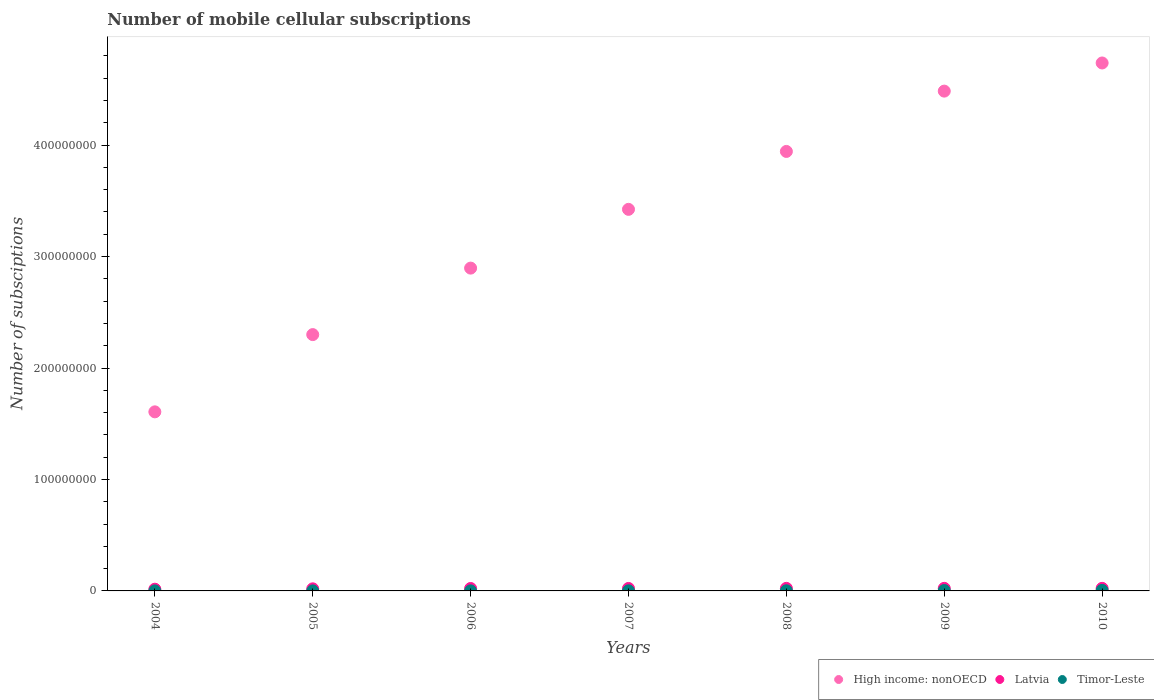What is the number of mobile cellular subscriptions in Latvia in 2010?
Provide a succinct answer. 2.31e+06. Across all years, what is the maximum number of mobile cellular subscriptions in Timor-Leste?
Keep it short and to the point. 4.73e+05. Across all years, what is the minimum number of mobile cellular subscriptions in Timor-Leste?
Your response must be concise. 2.57e+04. In which year was the number of mobile cellular subscriptions in High income: nonOECD maximum?
Offer a terse response. 2010. What is the total number of mobile cellular subscriptions in Latvia in the graph?
Your response must be concise. 1.47e+07. What is the difference between the number of mobile cellular subscriptions in Latvia in 2008 and that in 2009?
Your answer should be very brief. -4990. What is the difference between the number of mobile cellular subscriptions in Timor-Leste in 2006 and the number of mobile cellular subscriptions in Latvia in 2007?
Your response must be concise. -2.17e+06. What is the average number of mobile cellular subscriptions in High income: nonOECD per year?
Make the answer very short. 3.34e+08. In the year 2010, what is the difference between the number of mobile cellular subscriptions in Latvia and number of mobile cellular subscriptions in Timor-Leste?
Your response must be concise. 1.83e+06. What is the ratio of the number of mobile cellular subscriptions in High income: nonOECD in 2005 to that in 2010?
Give a very brief answer. 0.49. Is the number of mobile cellular subscriptions in High income: nonOECD in 2008 less than that in 2010?
Make the answer very short. Yes. What is the difference between the highest and the second highest number of mobile cellular subscriptions in High income: nonOECD?
Your answer should be very brief. 2.53e+07. What is the difference between the highest and the lowest number of mobile cellular subscriptions in Latvia?
Provide a short and direct response. 7.69e+05. Is it the case that in every year, the sum of the number of mobile cellular subscriptions in Latvia and number of mobile cellular subscriptions in Timor-Leste  is greater than the number of mobile cellular subscriptions in High income: nonOECD?
Your answer should be very brief. No. How many years are there in the graph?
Provide a succinct answer. 7. What is the difference between two consecutive major ticks on the Y-axis?
Provide a succinct answer. 1.00e+08. Are the values on the major ticks of Y-axis written in scientific E-notation?
Keep it short and to the point. No. How many legend labels are there?
Give a very brief answer. 3. What is the title of the graph?
Provide a short and direct response. Number of mobile cellular subscriptions. What is the label or title of the X-axis?
Your answer should be compact. Years. What is the label or title of the Y-axis?
Give a very brief answer. Number of subsciptions. What is the Number of subsciptions in High income: nonOECD in 2004?
Offer a very short reply. 1.61e+08. What is the Number of subsciptions of Latvia in 2004?
Give a very brief answer. 1.54e+06. What is the Number of subsciptions of Timor-Leste in 2004?
Your answer should be very brief. 2.57e+04. What is the Number of subsciptions in High income: nonOECD in 2005?
Your response must be concise. 2.30e+08. What is the Number of subsciptions in Latvia in 2005?
Your response must be concise. 1.87e+06. What is the Number of subsciptions in Timor-Leste in 2005?
Your answer should be compact. 3.31e+04. What is the Number of subsciptions in High income: nonOECD in 2006?
Provide a short and direct response. 2.90e+08. What is the Number of subsciptions of Latvia in 2006?
Your answer should be very brief. 2.18e+06. What is the Number of subsciptions of Timor-Leste in 2006?
Keep it short and to the point. 4.91e+04. What is the Number of subsciptions in High income: nonOECD in 2007?
Your answer should be compact. 3.42e+08. What is the Number of subsciptions of Latvia in 2007?
Make the answer very short. 2.22e+06. What is the Number of subsciptions of Timor-Leste in 2007?
Give a very brief answer. 7.82e+04. What is the Number of subsciptions of High income: nonOECD in 2008?
Give a very brief answer. 3.94e+08. What is the Number of subsciptions of Latvia in 2008?
Keep it short and to the point. 2.30e+06. What is the Number of subsciptions in Timor-Leste in 2008?
Provide a succinct answer. 1.25e+05. What is the Number of subsciptions in High income: nonOECD in 2009?
Ensure brevity in your answer.  4.48e+08. What is the Number of subsciptions in Latvia in 2009?
Provide a short and direct response. 2.30e+06. What is the Number of subsciptions of Timor-Leste in 2009?
Your response must be concise. 3.51e+05. What is the Number of subsciptions in High income: nonOECD in 2010?
Your response must be concise. 4.74e+08. What is the Number of subsciptions in Latvia in 2010?
Keep it short and to the point. 2.31e+06. What is the Number of subsciptions of Timor-Leste in 2010?
Your response must be concise. 4.73e+05. Across all years, what is the maximum Number of subsciptions in High income: nonOECD?
Provide a succinct answer. 4.74e+08. Across all years, what is the maximum Number of subsciptions of Latvia?
Offer a terse response. 2.31e+06. Across all years, what is the maximum Number of subsciptions in Timor-Leste?
Make the answer very short. 4.73e+05. Across all years, what is the minimum Number of subsciptions of High income: nonOECD?
Ensure brevity in your answer.  1.61e+08. Across all years, what is the minimum Number of subsciptions in Latvia?
Your response must be concise. 1.54e+06. Across all years, what is the minimum Number of subsciptions of Timor-Leste?
Your answer should be compact. 2.57e+04. What is the total Number of subsciptions of High income: nonOECD in the graph?
Your answer should be compact. 2.34e+09. What is the total Number of subsciptions in Latvia in the graph?
Your response must be concise. 1.47e+07. What is the total Number of subsciptions of Timor-Leste in the graph?
Your answer should be very brief. 1.14e+06. What is the difference between the Number of subsciptions in High income: nonOECD in 2004 and that in 2005?
Provide a short and direct response. -6.93e+07. What is the difference between the Number of subsciptions of Latvia in 2004 and that in 2005?
Your response must be concise. -3.35e+05. What is the difference between the Number of subsciptions in Timor-Leste in 2004 and that in 2005?
Give a very brief answer. -7350. What is the difference between the Number of subsciptions of High income: nonOECD in 2004 and that in 2006?
Your answer should be very brief. -1.29e+08. What is the difference between the Number of subsciptions of Latvia in 2004 and that in 2006?
Offer a terse response. -6.47e+05. What is the difference between the Number of subsciptions in Timor-Leste in 2004 and that in 2006?
Provide a short and direct response. -2.34e+04. What is the difference between the Number of subsciptions in High income: nonOECD in 2004 and that in 2007?
Your response must be concise. -1.82e+08. What is the difference between the Number of subsciptions in Latvia in 2004 and that in 2007?
Offer a terse response. -6.80e+05. What is the difference between the Number of subsciptions of Timor-Leste in 2004 and that in 2007?
Offer a very short reply. -5.25e+04. What is the difference between the Number of subsciptions of High income: nonOECD in 2004 and that in 2008?
Ensure brevity in your answer.  -2.34e+08. What is the difference between the Number of subsciptions in Latvia in 2004 and that in 2008?
Offer a terse response. -7.62e+05. What is the difference between the Number of subsciptions in Timor-Leste in 2004 and that in 2008?
Provide a succinct answer. -9.93e+04. What is the difference between the Number of subsciptions in High income: nonOECD in 2004 and that in 2009?
Offer a terse response. -2.88e+08. What is the difference between the Number of subsciptions in Latvia in 2004 and that in 2009?
Provide a short and direct response. -7.67e+05. What is the difference between the Number of subsciptions of Timor-Leste in 2004 and that in 2009?
Give a very brief answer. -3.25e+05. What is the difference between the Number of subsciptions of High income: nonOECD in 2004 and that in 2010?
Provide a succinct answer. -3.13e+08. What is the difference between the Number of subsciptions of Latvia in 2004 and that in 2010?
Your response must be concise. -7.69e+05. What is the difference between the Number of subsciptions of Timor-Leste in 2004 and that in 2010?
Your response must be concise. -4.47e+05. What is the difference between the Number of subsciptions in High income: nonOECD in 2005 and that in 2006?
Provide a succinct answer. -5.97e+07. What is the difference between the Number of subsciptions of Latvia in 2005 and that in 2006?
Provide a short and direct response. -3.12e+05. What is the difference between the Number of subsciptions in Timor-Leste in 2005 and that in 2006?
Give a very brief answer. -1.60e+04. What is the difference between the Number of subsciptions in High income: nonOECD in 2005 and that in 2007?
Provide a short and direct response. -1.12e+08. What is the difference between the Number of subsciptions of Latvia in 2005 and that in 2007?
Make the answer very short. -3.45e+05. What is the difference between the Number of subsciptions of Timor-Leste in 2005 and that in 2007?
Give a very brief answer. -4.51e+04. What is the difference between the Number of subsciptions in High income: nonOECD in 2005 and that in 2008?
Make the answer very short. -1.64e+08. What is the difference between the Number of subsciptions in Latvia in 2005 and that in 2008?
Your answer should be very brief. -4.27e+05. What is the difference between the Number of subsciptions of Timor-Leste in 2005 and that in 2008?
Give a very brief answer. -9.19e+04. What is the difference between the Number of subsciptions of High income: nonOECD in 2005 and that in 2009?
Offer a terse response. -2.18e+08. What is the difference between the Number of subsciptions in Latvia in 2005 and that in 2009?
Your response must be concise. -4.32e+05. What is the difference between the Number of subsciptions of Timor-Leste in 2005 and that in 2009?
Offer a terse response. -3.18e+05. What is the difference between the Number of subsciptions of High income: nonOECD in 2005 and that in 2010?
Your answer should be very brief. -2.44e+08. What is the difference between the Number of subsciptions in Latvia in 2005 and that in 2010?
Your answer should be compact. -4.34e+05. What is the difference between the Number of subsciptions in Timor-Leste in 2005 and that in 2010?
Offer a very short reply. -4.40e+05. What is the difference between the Number of subsciptions in High income: nonOECD in 2006 and that in 2007?
Provide a short and direct response. -5.27e+07. What is the difference between the Number of subsciptions of Latvia in 2006 and that in 2007?
Offer a terse response. -3.33e+04. What is the difference between the Number of subsciptions of Timor-Leste in 2006 and that in 2007?
Ensure brevity in your answer.  -2.91e+04. What is the difference between the Number of subsciptions of High income: nonOECD in 2006 and that in 2008?
Make the answer very short. -1.05e+08. What is the difference between the Number of subsciptions in Latvia in 2006 and that in 2008?
Give a very brief answer. -1.15e+05. What is the difference between the Number of subsciptions of Timor-Leste in 2006 and that in 2008?
Your response must be concise. -7.59e+04. What is the difference between the Number of subsciptions of High income: nonOECD in 2006 and that in 2009?
Offer a terse response. -1.59e+08. What is the difference between the Number of subsciptions of Latvia in 2006 and that in 2009?
Your answer should be compact. -1.20e+05. What is the difference between the Number of subsciptions of Timor-Leste in 2006 and that in 2009?
Provide a succinct answer. -3.02e+05. What is the difference between the Number of subsciptions of High income: nonOECD in 2006 and that in 2010?
Offer a very short reply. -1.84e+08. What is the difference between the Number of subsciptions in Latvia in 2006 and that in 2010?
Give a very brief answer. -1.22e+05. What is the difference between the Number of subsciptions of Timor-Leste in 2006 and that in 2010?
Ensure brevity in your answer.  -4.24e+05. What is the difference between the Number of subsciptions of High income: nonOECD in 2007 and that in 2008?
Provide a succinct answer. -5.20e+07. What is the difference between the Number of subsciptions of Latvia in 2007 and that in 2008?
Your answer should be compact. -8.16e+04. What is the difference between the Number of subsciptions in Timor-Leste in 2007 and that in 2008?
Offer a terse response. -4.68e+04. What is the difference between the Number of subsciptions in High income: nonOECD in 2007 and that in 2009?
Provide a short and direct response. -1.06e+08. What is the difference between the Number of subsciptions in Latvia in 2007 and that in 2009?
Keep it short and to the point. -8.66e+04. What is the difference between the Number of subsciptions of Timor-Leste in 2007 and that in 2009?
Offer a terse response. -2.73e+05. What is the difference between the Number of subsciptions of High income: nonOECD in 2007 and that in 2010?
Keep it short and to the point. -1.31e+08. What is the difference between the Number of subsciptions in Latvia in 2007 and that in 2010?
Provide a short and direct response. -8.91e+04. What is the difference between the Number of subsciptions in Timor-Leste in 2007 and that in 2010?
Your response must be concise. -3.95e+05. What is the difference between the Number of subsciptions of High income: nonOECD in 2008 and that in 2009?
Provide a short and direct response. -5.41e+07. What is the difference between the Number of subsciptions of Latvia in 2008 and that in 2009?
Provide a short and direct response. -4990. What is the difference between the Number of subsciptions in Timor-Leste in 2008 and that in 2009?
Your answer should be compact. -2.26e+05. What is the difference between the Number of subsciptions in High income: nonOECD in 2008 and that in 2010?
Your response must be concise. -7.94e+07. What is the difference between the Number of subsciptions of Latvia in 2008 and that in 2010?
Provide a succinct answer. -7490. What is the difference between the Number of subsciptions in Timor-Leste in 2008 and that in 2010?
Give a very brief answer. -3.48e+05. What is the difference between the Number of subsciptions of High income: nonOECD in 2009 and that in 2010?
Provide a succinct answer. -2.53e+07. What is the difference between the Number of subsciptions of Latvia in 2009 and that in 2010?
Your answer should be compact. -2500. What is the difference between the Number of subsciptions in Timor-Leste in 2009 and that in 2010?
Provide a short and direct response. -1.22e+05. What is the difference between the Number of subsciptions in High income: nonOECD in 2004 and the Number of subsciptions in Latvia in 2005?
Your answer should be compact. 1.59e+08. What is the difference between the Number of subsciptions in High income: nonOECD in 2004 and the Number of subsciptions in Timor-Leste in 2005?
Make the answer very short. 1.61e+08. What is the difference between the Number of subsciptions in Latvia in 2004 and the Number of subsciptions in Timor-Leste in 2005?
Offer a terse response. 1.50e+06. What is the difference between the Number of subsciptions of High income: nonOECD in 2004 and the Number of subsciptions of Latvia in 2006?
Make the answer very short. 1.58e+08. What is the difference between the Number of subsciptions of High income: nonOECD in 2004 and the Number of subsciptions of Timor-Leste in 2006?
Keep it short and to the point. 1.61e+08. What is the difference between the Number of subsciptions in Latvia in 2004 and the Number of subsciptions in Timor-Leste in 2006?
Provide a succinct answer. 1.49e+06. What is the difference between the Number of subsciptions of High income: nonOECD in 2004 and the Number of subsciptions of Latvia in 2007?
Keep it short and to the point. 1.58e+08. What is the difference between the Number of subsciptions of High income: nonOECD in 2004 and the Number of subsciptions of Timor-Leste in 2007?
Give a very brief answer. 1.61e+08. What is the difference between the Number of subsciptions of Latvia in 2004 and the Number of subsciptions of Timor-Leste in 2007?
Offer a terse response. 1.46e+06. What is the difference between the Number of subsciptions of High income: nonOECD in 2004 and the Number of subsciptions of Latvia in 2008?
Your response must be concise. 1.58e+08. What is the difference between the Number of subsciptions of High income: nonOECD in 2004 and the Number of subsciptions of Timor-Leste in 2008?
Provide a short and direct response. 1.61e+08. What is the difference between the Number of subsciptions of Latvia in 2004 and the Number of subsciptions of Timor-Leste in 2008?
Your answer should be compact. 1.41e+06. What is the difference between the Number of subsciptions in High income: nonOECD in 2004 and the Number of subsciptions in Latvia in 2009?
Offer a very short reply. 1.58e+08. What is the difference between the Number of subsciptions in High income: nonOECD in 2004 and the Number of subsciptions in Timor-Leste in 2009?
Your answer should be very brief. 1.60e+08. What is the difference between the Number of subsciptions of Latvia in 2004 and the Number of subsciptions of Timor-Leste in 2009?
Offer a terse response. 1.19e+06. What is the difference between the Number of subsciptions in High income: nonOECD in 2004 and the Number of subsciptions in Latvia in 2010?
Make the answer very short. 1.58e+08. What is the difference between the Number of subsciptions of High income: nonOECD in 2004 and the Number of subsciptions of Timor-Leste in 2010?
Provide a short and direct response. 1.60e+08. What is the difference between the Number of subsciptions in Latvia in 2004 and the Number of subsciptions in Timor-Leste in 2010?
Provide a succinct answer. 1.06e+06. What is the difference between the Number of subsciptions of High income: nonOECD in 2005 and the Number of subsciptions of Latvia in 2006?
Make the answer very short. 2.28e+08. What is the difference between the Number of subsciptions in High income: nonOECD in 2005 and the Number of subsciptions in Timor-Leste in 2006?
Offer a very short reply. 2.30e+08. What is the difference between the Number of subsciptions in Latvia in 2005 and the Number of subsciptions in Timor-Leste in 2006?
Give a very brief answer. 1.82e+06. What is the difference between the Number of subsciptions of High income: nonOECD in 2005 and the Number of subsciptions of Latvia in 2007?
Make the answer very short. 2.28e+08. What is the difference between the Number of subsciptions of High income: nonOECD in 2005 and the Number of subsciptions of Timor-Leste in 2007?
Give a very brief answer. 2.30e+08. What is the difference between the Number of subsciptions in Latvia in 2005 and the Number of subsciptions in Timor-Leste in 2007?
Offer a very short reply. 1.79e+06. What is the difference between the Number of subsciptions in High income: nonOECD in 2005 and the Number of subsciptions in Latvia in 2008?
Ensure brevity in your answer.  2.28e+08. What is the difference between the Number of subsciptions in High income: nonOECD in 2005 and the Number of subsciptions in Timor-Leste in 2008?
Your answer should be very brief. 2.30e+08. What is the difference between the Number of subsciptions in Latvia in 2005 and the Number of subsciptions in Timor-Leste in 2008?
Offer a terse response. 1.75e+06. What is the difference between the Number of subsciptions of High income: nonOECD in 2005 and the Number of subsciptions of Latvia in 2009?
Make the answer very short. 2.28e+08. What is the difference between the Number of subsciptions in High income: nonOECD in 2005 and the Number of subsciptions in Timor-Leste in 2009?
Keep it short and to the point. 2.30e+08. What is the difference between the Number of subsciptions in Latvia in 2005 and the Number of subsciptions in Timor-Leste in 2009?
Make the answer very short. 1.52e+06. What is the difference between the Number of subsciptions in High income: nonOECD in 2005 and the Number of subsciptions in Latvia in 2010?
Your answer should be compact. 2.28e+08. What is the difference between the Number of subsciptions of High income: nonOECD in 2005 and the Number of subsciptions of Timor-Leste in 2010?
Ensure brevity in your answer.  2.30e+08. What is the difference between the Number of subsciptions of Latvia in 2005 and the Number of subsciptions of Timor-Leste in 2010?
Offer a very short reply. 1.40e+06. What is the difference between the Number of subsciptions of High income: nonOECD in 2006 and the Number of subsciptions of Latvia in 2007?
Provide a succinct answer. 2.87e+08. What is the difference between the Number of subsciptions in High income: nonOECD in 2006 and the Number of subsciptions in Timor-Leste in 2007?
Offer a very short reply. 2.90e+08. What is the difference between the Number of subsciptions of Latvia in 2006 and the Number of subsciptions of Timor-Leste in 2007?
Provide a succinct answer. 2.11e+06. What is the difference between the Number of subsciptions in High income: nonOECD in 2006 and the Number of subsciptions in Latvia in 2008?
Ensure brevity in your answer.  2.87e+08. What is the difference between the Number of subsciptions of High income: nonOECD in 2006 and the Number of subsciptions of Timor-Leste in 2008?
Keep it short and to the point. 2.90e+08. What is the difference between the Number of subsciptions of Latvia in 2006 and the Number of subsciptions of Timor-Leste in 2008?
Your answer should be very brief. 2.06e+06. What is the difference between the Number of subsciptions in High income: nonOECD in 2006 and the Number of subsciptions in Latvia in 2009?
Provide a short and direct response. 2.87e+08. What is the difference between the Number of subsciptions of High income: nonOECD in 2006 and the Number of subsciptions of Timor-Leste in 2009?
Offer a terse response. 2.89e+08. What is the difference between the Number of subsciptions in Latvia in 2006 and the Number of subsciptions in Timor-Leste in 2009?
Your answer should be compact. 1.83e+06. What is the difference between the Number of subsciptions in High income: nonOECD in 2006 and the Number of subsciptions in Latvia in 2010?
Provide a short and direct response. 2.87e+08. What is the difference between the Number of subsciptions in High income: nonOECD in 2006 and the Number of subsciptions in Timor-Leste in 2010?
Make the answer very short. 2.89e+08. What is the difference between the Number of subsciptions in Latvia in 2006 and the Number of subsciptions in Timor-Leste in 2010?
Provide a succinct answer. 1.71e+06. What is the difference between the Number of subsciptions in High income: nonOECD in 2007 and the Number of subsciptions in Latvia in 2008?
Your answer should be very brief. 3.40e+08. What is the difference between the Number of subsciptions in High income: nonOECD in 2007 and the Number of subsciptions in Timor-Leste in 2008?
Provide a short and direct response. 3.42e+08. What is the difference between the Number of subsciptions in Latvia in 2007 and the Number of subsciptions in Timor-Leste in 2008?
Make the answer very short. 2.09e+06. What is the difference between the Number of subsciptions in High income: nonOECD in 2007 and the Number of subsciptions in Latvia in 2009?
Ensure brevity in your answer.  3.40e+08. What is the difference between the Number of subsciptions of High income: nonOECD in 2007 and the Number of subsciptions of Timor-Leste in 2009?
Give a very brief answer. 3.42e+08. What is the difference between the Number of subsciptions in Latvia in 2007 and the Number of subsciptions in Timor-Leste in 2009?
Your answer should be compact. 1.87e+06. What is the difference between the Number of subsciptions in High income: nonOECD in 2007 and the Number of subsciptions in Latvia in 2010?
Make the answer very short. 3.40e+08. What is the difference between the Number of subsciptions in High income: nonOECD in 2007 and the Number of subsciptions in Timor-Leste in 2010?
Make the answer very short. 3.42e+08. What is the difference between the Number of subsciptions of Latvia in 2007 and the Number of subsciptions of Timor-Leste in 2010?
Your answer should be very brief. 1.74e+06. What is the difference between the Number of subsciptions in High income: nonOECD in 2008 and the Number of subsciptions in Latvia in 2009?
Your answer should be compact. 3.92e+08. What is the difference between the Number of subsciptions of High income: nonOECD in 2008 and the Number of subsciptions of Timor-Leste in 2009?
Keep it short and to the point. 3.94e+08. What is the difference between the Number of subsciptions in Latvia in 2008 and the Number of subsciptions in Timor-Leste in 2009?
Provide a succinct answer. 1.95e+06. What is the difference between the Number of subsciptions in High income: nonOECD in 2008 and the Number of subsciptions in Latvia in 2010?
Offer a terse response. 3.92e+08. What is the difference between the Number of subsciptions of High income: nonOECD in 2008 and the Number of subsciptions of Timor-Leste in 2010?
Ensure brevity in your answer.  3.94e+08. What is the difference between the Number of subsciptions in Latvia in 2008 and the Number of subsciptions in Timor-Leste in 2010?
Provide a short and direct response. 1.83e+06. What is the difference between the Number of subsciptions in High income: nonOECD in 2009 and the Number of subsciptions in Latvia in 2010?
Your response must be concise. 4.46e+08. What is the difference between the Number of subsciptions in High income: nonOECD in 2009 and the Number of subsciptions in Timor-Leste in 2010?
Your answer should be very brief. 4.48e+08. What is the difference between the Number of subsciptions in Latvia in 2009 and the Number of subsciptions in Timor-Leste in 2010?
Provide a succinct answer. 1.83e+06. What is the average Number of subsciptions of High income: nonOECD per year?
Ensure brevity in your answer.  3.34e+08. What is the average Number of subsciptions of Latvia per year?
Your answer should be very brief. 2.10e+06. What is the average Number of subsciptions of Timor-Leste per year?
Your response must be concise. 1.62e+05. In the year 2004, what is the difference between the Number of subsciptions of High income: nonOECD and Number of subsciptions of Latvia?
Give a very brief answer. 1.59e+08. In the year 2004, what is the difference between the Number of subsciptions in High income: nonOECD and Number of subsciptions in Timor-Leste?
Provide a short and direct response. 1.61e+08. In the year 2004, what is the difference between the Number of subsciptions of Latvia and Number of subsciptions of Timor-Leste?
Your answer should be compact. 1.51e+06. In the year 2005, what is the difference between the Number of subsciptions in High income: nonOECD and Number of subsciptions in Latvia?
Give a very brief answer. 2.28e+08. In the year 2005, what is the difference between the Number of subsciptions of High income: nonOECD and Number of subsciptions of Timor-Leste?
Your response must be concise. 2.30e+08. In the year 2005, what is the difference between the Number of subsciptions in Latvia and Number of subsciptions in Timor-Leste?
Provide a short and direct response. 1.84e+06. In the year 2006, what is the difference between the Number of subsciptions of High income: nonOECD and Number of subsciptions of Latvia?
Offer a very short reply. 2.87e+08. In the year 2006, what is the difference between the Number of subsciptions of High income: nonOECD and Number of subsciptions of Timor-Leste?
Provide a succinct answer. 2.90e+08. In the year 2006, what is the difference between the Number of subsciptions in Latvia and Number of subsciptions in Timor-Leste?
Provide a short and direct response. 2.13e+06. In the year 2007, what is the difference between the Number of subsciptions in High income: nonOECD and Number of subsciptions in Latvia?
Ensure brevity in your answer.  3.40e+08. In the year 2007, what is the difference between the Number of subsciptions in High income: nonOECD and Number of subsciptions in Timor-Leste?
Keep it short and to the point. 3.42e+08. In the year 2007, what is the difference between the Number of subsciptions in Latvia and Number of subsciptions in Timor-Leste?
Make the answer very short. 2.14e+06. In the year 2008, what is the difference between the Number of subsciptions of High income: nonOECD and Number of subsciptions of Latvia?
Your answer should be very brief. 3.92e+08. In the year 2008, what is the difference between the Number of subsciptions in High income: nonOECD and Number of subsciptions in Timor-Leste?
Your response must be concise. 3.94e+08. In the year 2008, what is the difference between the Number of subsciptions of Latvia and Number of subsciptions of Timor-Leste?
Your answer should be very brief. 2.17e+06. In the year 2009, what is the difference between the Number of subsciptions of High income: nonOECD and Number of subsciptions of Latvia?
Offer a very short reply. 4.46e+08. In the year 2009, what is the difference between the Number of subsciptions of High income: nonOECD and Number of subsciptions of Timor-Leste?
Give a very brief answer. 4.48e+08. In the year 2009, what is the difference between the Number of subsciptions of Latvia and Number of subsciptions of Timor-Leste?
Your response must be concise. 1.95e+06. In the year 2010, what is the difference between the Number of subsciptions in High income: nonOECD and Number of subsciptions in Latvia?
Your answer should be compact. 4.71e+08. In the year 2010, what is the difference between the Number of subsciptions of High income: nonOECD and Number of subsciptions of Timor-Leste?
Offer a very short reply. 4.73e+08. In the year 2010, what is the difference between the Number of subsciptions of Latvia and Number of subsciptions of Timor-Leste?
Your answer should be compact. 1.83e+06. What is the ratio of the Number of subsciptions in High income: nonOECD in 2004 to that in 2005?
Your answer should be very brief. 0.7. What is the ratio of the Number of subsciptions in Latvia in 2004 to that in 2005?
Provide a short and direct response. 0.82. What is the ratio of the Number of subsciptions of High income: nonOECD in 2004 to that in 2006?
Ensure brevity in your answer.  0.55. What is the ratio of the Number of subsciptions in Latvia in 2004 to that in 2006?
Ensure brevity in your answer.  0.7. What is the ratio of the Number of subsciptions in Timor-Leste in 2004 to that in 2006?
Offer a terse response. 0.52. What is the ratio of the Number of subsciptions of High income: nonOECD in 2004 to that in 2007?
Make the answer very short. 0.47. What is the ratio of the Number of subsciptions of Latvia in 2004 to that in 2007?
Ensure brevity in your answer.  0.69. What is the ratio of the Number of subsciptions in Timor-Leste in 2004 to that in 2007?
Provide a short and direct response. 0.33. What is the ratio of the Number of subsciptions in High income: nonOECD in 2004 to that in 2008?
Make the answer very short. 0.41. What is the ratio of the Number of subsciptions of Latvia in 2004 to that in 2008?
Keep it short and to the point. 0.67. What is the ratio of the Number of subsciptions in Timor-Leste in 2004 to that in 2008?
Your answer should be very brief. 0.21. What is the ratio of the Number of subsciptions in High income: nonOECD in 2004 to that in 2009?
Provide a short and direct response. 0.36. What is the ratio of the Number of subsciptions in Latvia in 2004 to that in 2009?
Make the answer very short. 0.67. What is the ratio of the Number of subsciptions in Timor-Leste in 2004 to that in 2009?
Offer a very short reply. 0.07. What is the ratio of the Number of subsciptions in High income: nonOECD in 2004 to that in 2010?
Provide a short and direct response. 0.34. What is the ratio of the Number of subsciptions in Latvia in 2004 to that in 2010?
Offer a very short reply. 0.67. What is the ratio of the Number of subsciptions in Timor-Leste in 2004 to that in 2010?
Ensure brevity in your answer.  0.05. What is the ratio of the Number of subsciptions in High income: nonOECD in 2005 to that in 2006?
Ensure brevity in your answer.  0.79. What is the ratio of the Number of subsciptions of Latvia in 2005 to that in 2006?
Give a very brief answer. 0.86. What is the ratio of the Number of subsciptions in Timor-Leste in 2005 to that in 2006?
Ensure brevity in your answer.  0.67. What is the ratio of the Number of subsciptions of High income: nonOECD in 2005 to that in 2007?
Your answer should be compact. 0.67. What is the ratio of the Number of subsciptions of Latvia in 2005 to that in 2007?
Your answer should be very brief. 0.84. What is the ratio of the Number of subsciptions of Timor-Leste in 2005 to that in 2007?
Your response must be concise. 0.42. What is the ratio of the Number of subsciptions in High income: nonOECD in 2005 to that in 2008?
Your response must be concise. 0.58. What is the ratio of the Number of subsciptions in Latvia in 2005 to that in 2008?
Your response must be concise. 0.81. What is the ratio of the Number of subsciptions in Timor-Leste in 2005 to that in 2008?
Your answer should be compact. 0.26. What is the ratio of the Number of subsciptions of High income: nonOECD in 2005 to that in 2009?
Provide a short and direct response. 0.51. What is the ratio of the Number of subsciptions of Latvia in 2005 to that in 2009?
Offer a terse response. 0.81. What is the ratio of the Number of subsciptions of Timor-Leste in 2005 to that in 2009?
Your answer should be compact. 0.09. What is the ratio of the Number of subsciptions of High income: nonOECD in 2005 to that in 2010?
Your response must be concise. 0.49. What is the ratio of the Number of subsciptions of Latvia in 2005 to that in 2010?
Keep it short and to the point. 0.81. What is the ratio of the Number of subsciptions in Timor-Leste in 2005 to that in 2010?
Offer a terse response. 0.07. What is the ratio of the Number of subsciptions in High income: nonOECD in 2006 to that in 2007?
Your response must be concise. 0.85. What is the ratio of the Number of subsciptions in Latvia in 2006 to that in 2007?
Provide a succinct answer. 0.98. What is the ratio of the Number of subsciptions of Timor-Leste in 2006 to that in 2007?
Provide a succinct answer. 0.63. What is the ratio of the Number of subsciptions in High income: nonOECD in 2006 to that in 2008?
Offer a terse response. 0.73. What is the ratio of the Number of subsciptions of Latvia in 2006 to that in 2008?
Provide a short and direct response. 0.95. What is the ratio of the Number of subsciptions of Timor-Leste in 2006 to that in 2008?
Your answer should be very brief. 0.39. What is the ratio of the Number of subsciptions of High income: nonOECD in 2006 to that in 2009?
Provide a short and direct response. 0.65. What is the ratio of the Number of subsciptions of Latvia in 2006 to that in 2009?
Provide a short and direct response. 0.95. What is the ratio of the Number of subsciptions of Timor-Leste in 2006 to that in 2009?
Keep it short and to the point. 0.14. What is the ratio of the Number of subsciptions of High income: nonOECD in 2006 to that in 2010?
Offer a terse response. 0.61. What is the ratio of the Number of subsciptions in Latvia in 2006 to that in 2010?
Offer a very short reply. 0.95. What is the ratio of the Number of subsciptions of Timor-Leste in 2006 to that in 2010?
Keep it short and to the point. 0.1. What is the ratio of the Number of subsciptions of High income: nonOECD in 2007 to that in 2008?
Your response must be concise. 0.87. What is the ratio of the Number of subsciptions of Latvia in 2007 to that in 2008?
Give a very brief answer. 0.96. What is the ratio of the Number of subsciptions of Timor-Leste in 2007 to that in 2008?
Provide a succinct answer. 0.63. What is the ratio of the Number of subsciptions in High income: nonOECD in 2007 to that in 2009?
Your response must be concise. 0.76. What is the ratio of the Number of subsciptions of Latvia in 2007 to that in 2009?
Your answer should be compact. 0.96. What is the ratio of the Number of subsciptions in Timor-Leste in 2007 to that in 2009?
Provide a short and direct response. 0.22. What is the ratio of the Number of subsciptions in High income: nonOECD in 2007 to that in 2010?
Your answer should be compact. 0.72. What is the ratio of the Number of subsciptions in Latvia in 2007 to that in 2010?
Provide a succinct answer. 0.96. What is the ratio of the Number of subsciptions of Timor-Leste in 2007 to that in 2010?
Give a very brief answer. 0.17. What is the ratio of the Number of subsciptions of High income: nonOECD in 2008 to that in 2009?
Make the answer very short. 0.88. What is the ratio of the Number of subsciptions of Latvia in 2008 to that in 2009?
Keep it short and to the point. 1. What is the ratio of the Number of subsciptions of Timor-Leste in 2008 to that in 2009?
Provide a short and direct response. 0.36. What is the ratio of the Number of subsciptions in High income: nonOECD in 2008 to that in 2010?
Offer a very short reply. 0.83. What is the ratio of the Number of subsciptions in Latvia in 2008 to that in 2010?
Make the answer very short. 1. What is the ratio of the Number of subsciptions in Timor-Leste in 2008 to that in 2010?
Your response must be concise. 0.26. What is the ratio of the Number of subsciptions in High income: nonOECD in 2009 to that in 2010?
Provide a short and direct response. 0.95. What is the ratio of the Number of subsciptions of Timor-Leste in 2009 to that in 2010?
Your answer should be very brief. 0.74. What is the difference between the highest and the second highest Number of subsciptions of High income: nonOECD?
Your answer should be very brief. 2.53e+07. What is the difference between the highest and the second highest Number of subsciptions of Latvia?
Give a very brief answer. 2500. What is the difference between the highest and the second highest Number of subsciptions of Timor-Leste?
Your answer should be very brief. 1.22e+05. What is the difference between the highest and the lowest Number of subsciptions in High income: nonOECD?
Offer a terse response. 3.13e+08. What is the difference between the highest and the lowest Number of subsciptions in Latvia?
Provide a short and direct response. 7.69e+05. What is the difference between the highest and the lowest Number of subsciptions in Timor-Leste?
Provide a short and direct response. 4.47e+05. 